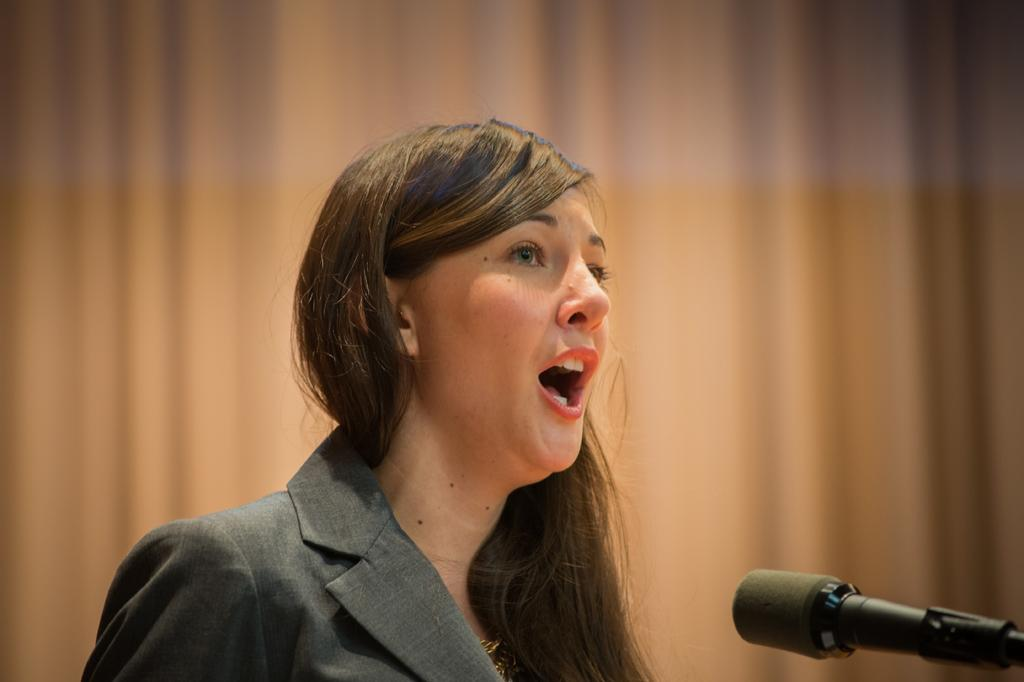Who is present in the image? There is a woman in the image. What is the woman doing? The woman is talking. What object is on the right side of the image? There is a microphone on the right side of the image. How would you describe the background of the image? The background of the image is creamy. How many rings can be seen on the woman's fingers in the image? There is no mention of rings in the image, so we cannot determine the number of rings on the woman's fingers. What type of vase is present in the image? There is no vase present in the image. 